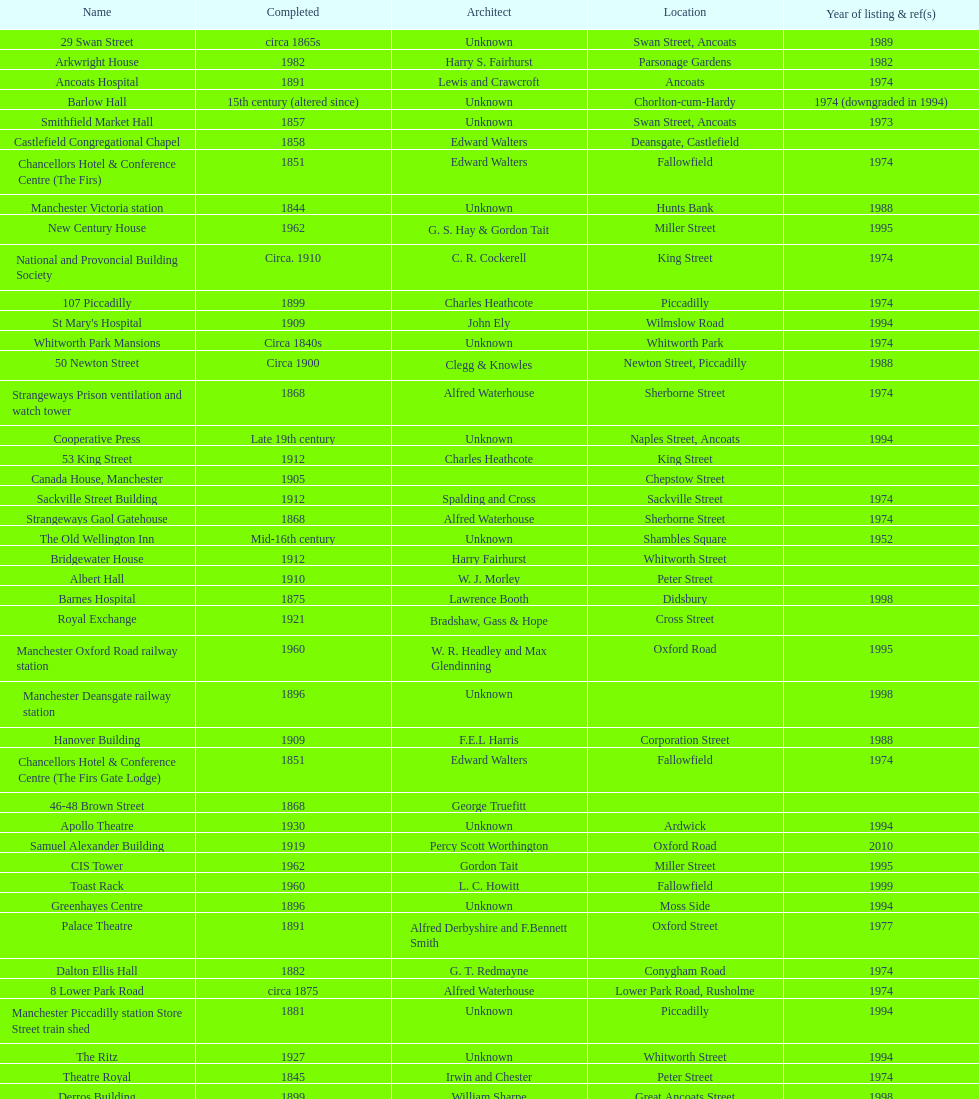What is the street of the only building listed in 1989? Swan Street. 